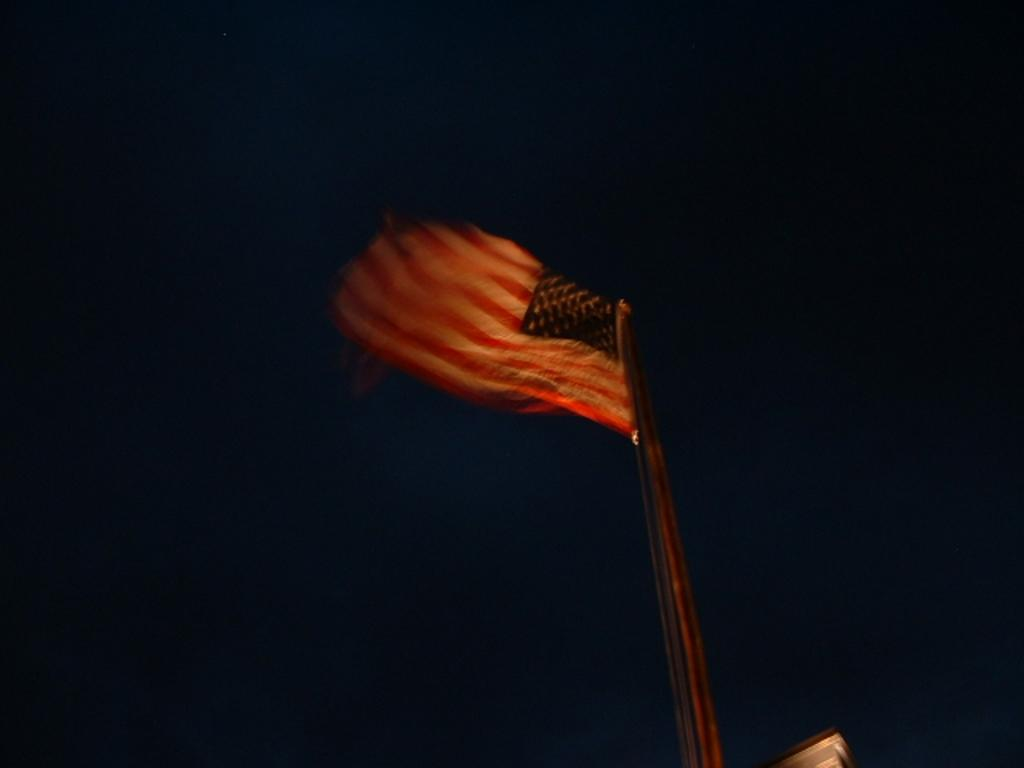What is present in the image that represents a country or organization? There is a flag in the image. How is the flag displayed in the image? The flag is on a pole. How many straws are entangled with the flagpole in the image? There are no straws present in the image, and the flagpole is not entangled with any objects. 